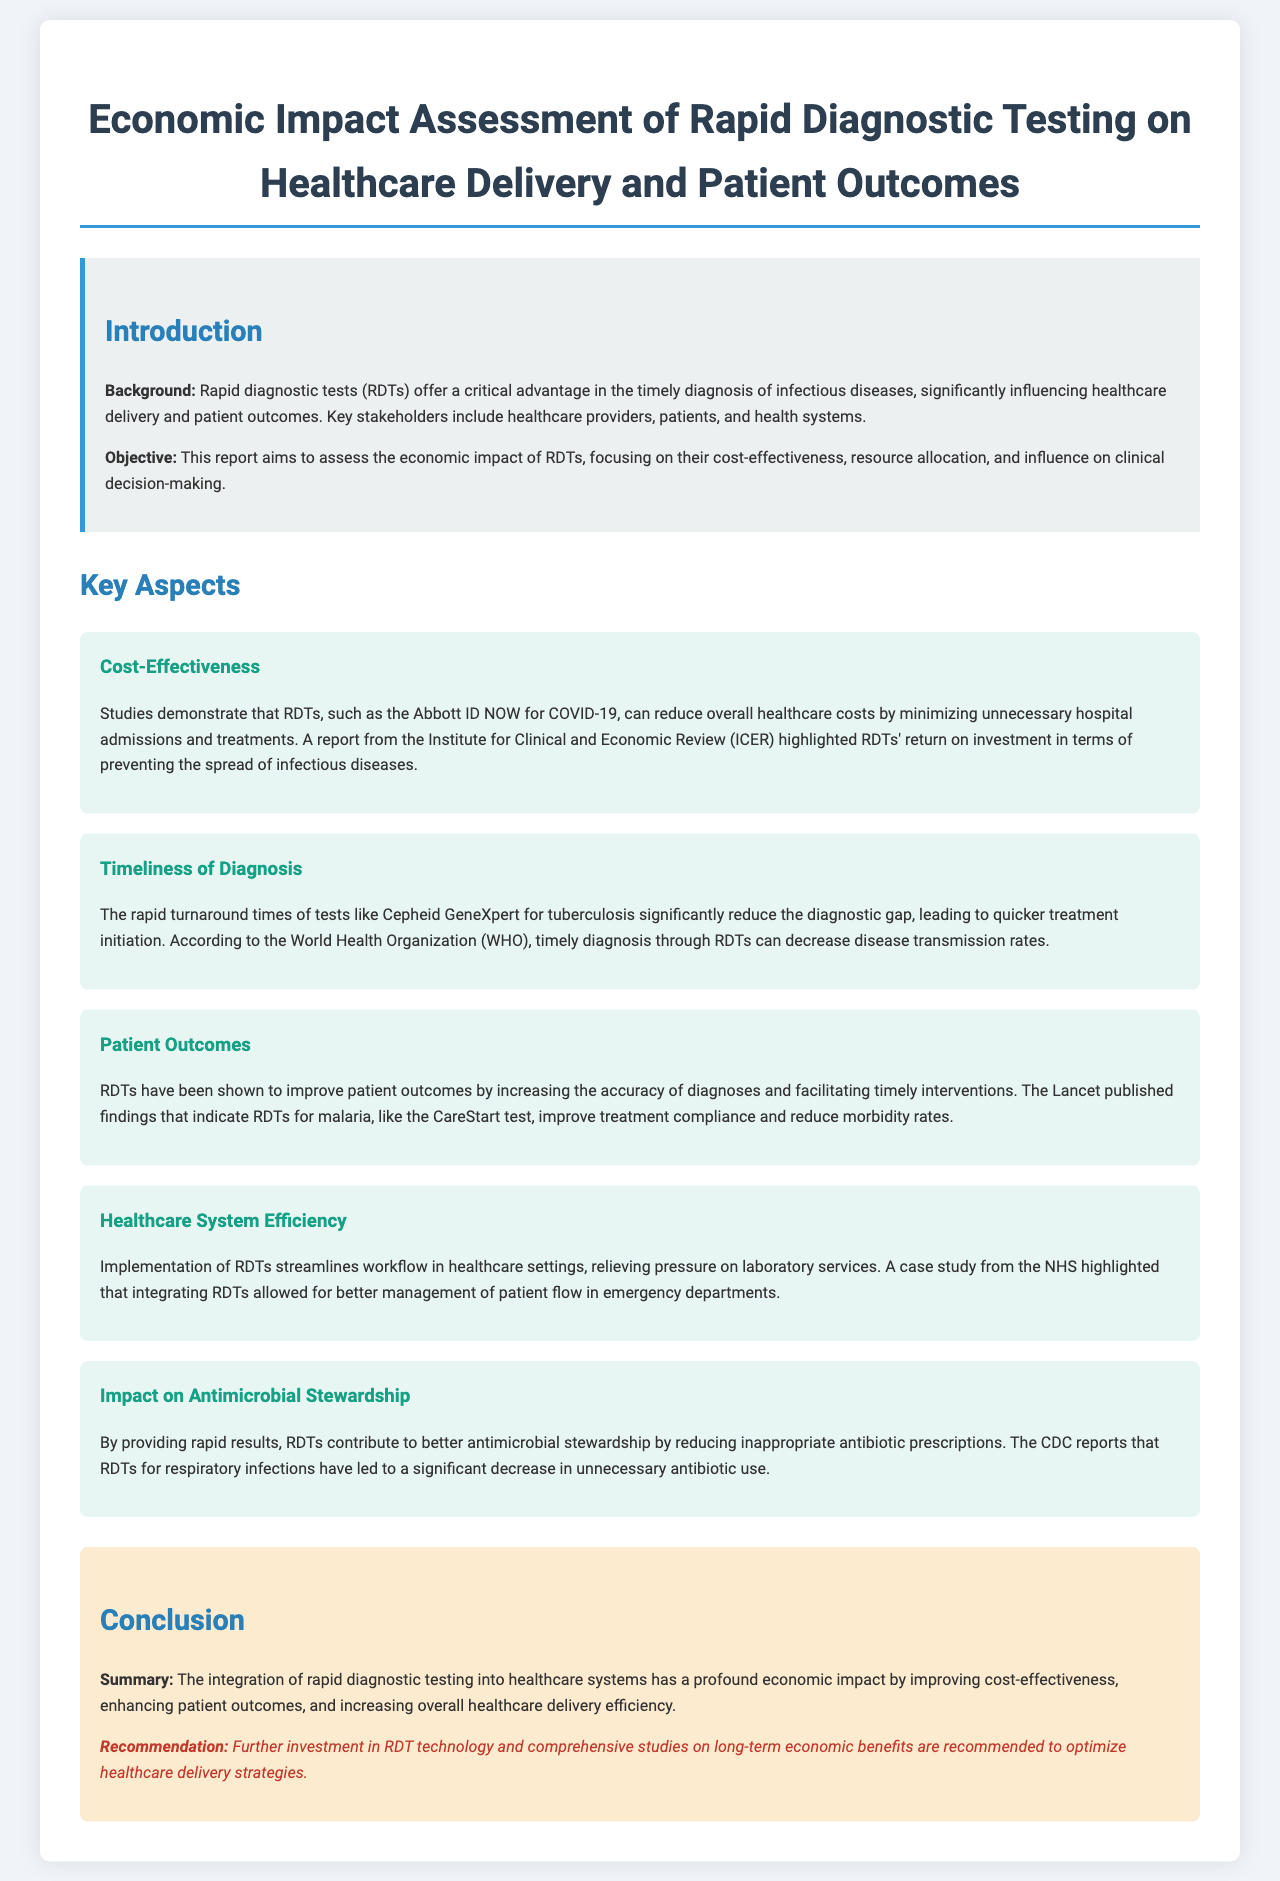What is the title of the report? The title of the report is a key piece of information stated at the top of the document.
Answer: Economic Impact Assessment of Rapid Diagnostic Testing on Healthcare Delivery and Patient Outcomes What is one example of a rapid diagnostic test mentioned in the report? The document lists specific RDTs, demonstrating their relevance to the topic.
Answer: Abbott ID NOW What organization reported the return on investment of RDTs? Understanding the sources of data enhances credibility and context in the report.
Answer: Institute for Clinical and Economic Review What is the primary benefit of rapid diagnostic tests according to the document? The main benefit highlighted in the report summarizes the overarching impact of RDTs.
Answer: Timely diagnosis Which infectious disease's RDT is associated with improved treatment compliance? The report connects specific tests to their benefits, focusing on patient outcomes.
Answer: Malaria What recommendation is made regarding rapid diagnostic testing? Recommendations often encapsulate the document's conclusions on future actions to take.
Answer: Further investment in RDT technology Which healthcare system's case study is mentioned in the report? Mentioning specific healthcare systems showcases real-world applications of the findings.
Answer: NHS What type of stewardship do RDTs impact according to the report? Identifying specific domains affected by the RDTs helps in understanding broader implications.
Answer: Antimicrobial stewardship 